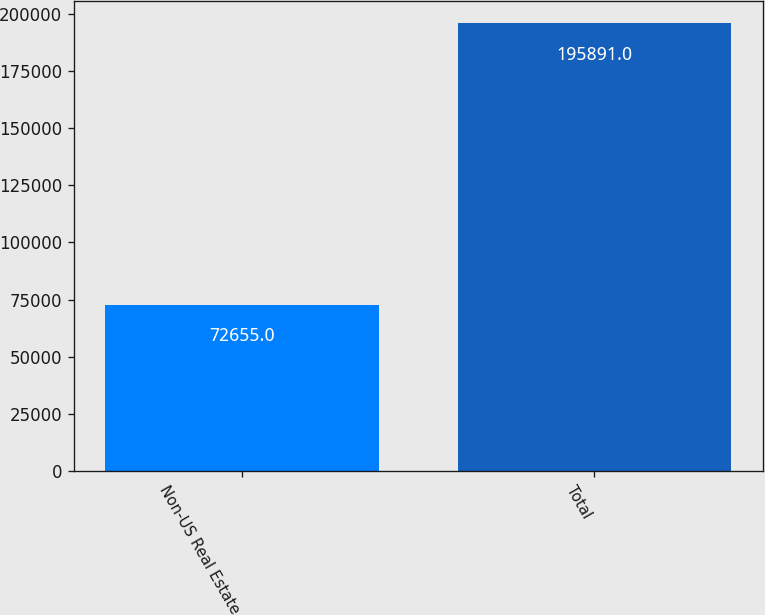<chart> <loc_0><loc_0><loc_500><loc_500><bar_chart><fcel>Non-US Real Estate<fcel>Total<nl><fcel>72655<fcel>195891<nl></chart> 